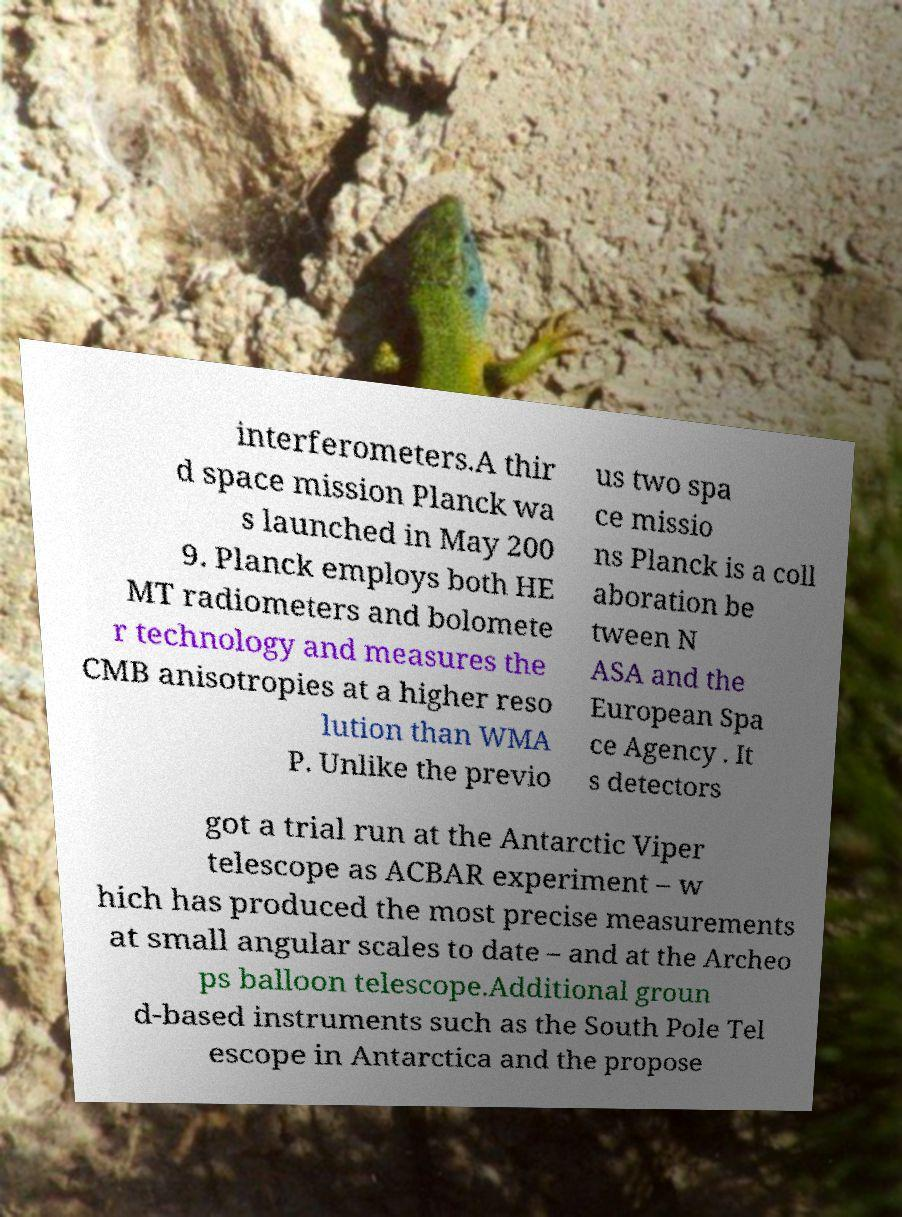Could you assist in decoding the text presented in this image and type it out clearly? interferometers.A thir d space mission Planck wa s launched in May 200 9. Planck employs both HE MT radiometers and bolomete r technology and measures the CMB anisotropies at a higher reso lution than WMA P. Unlike the previo us two spa ce missio ns Planck is a coll aboration be tween N ASA and the European Spa ce Agency . It s detectors got a trial run at the Antarctic Viper telescope as ACBAR experiment – w hich has produced the most precise measurements at small angular scales to date – and at the Archeo ps balloon telescope.Additional groun d-based instruments such as the South Pole Tel escope in Antarctica and the propose 